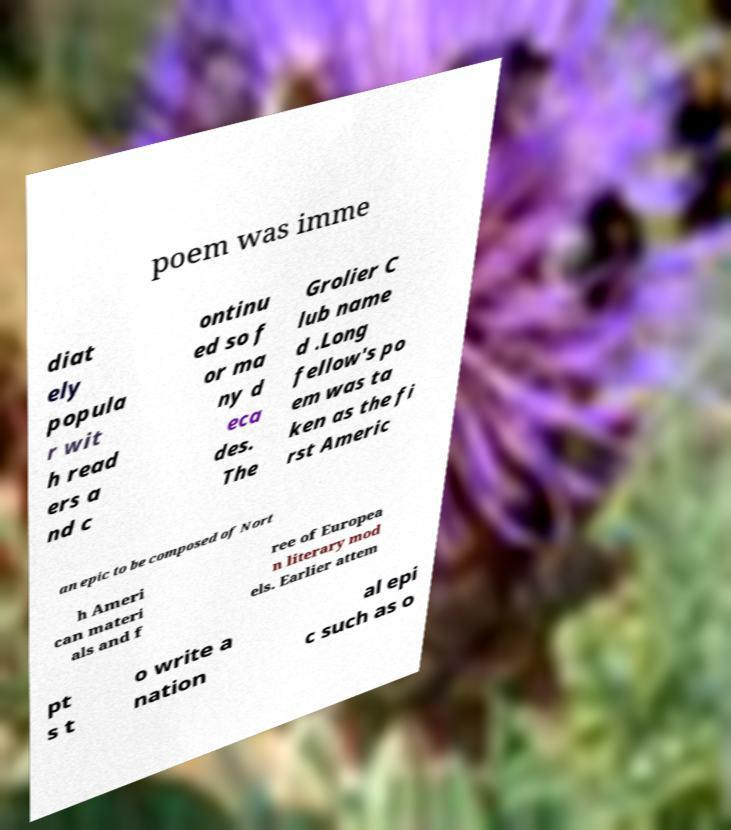For documentation purposes, I need the text within this image transcribed. Could you provide that? poem was imme diat ely popula r wit h read ers a nd c ontinu ed so f or ma ny d eca des. The Grolier C lub name d .Long fellow's po em was ta ken as the fi rst Americ an epic to be composed of Nort h Ameri can materi als and f ree of Europea n literary mod els. Earlier attem pt s t o write a nation al epi c such as o 